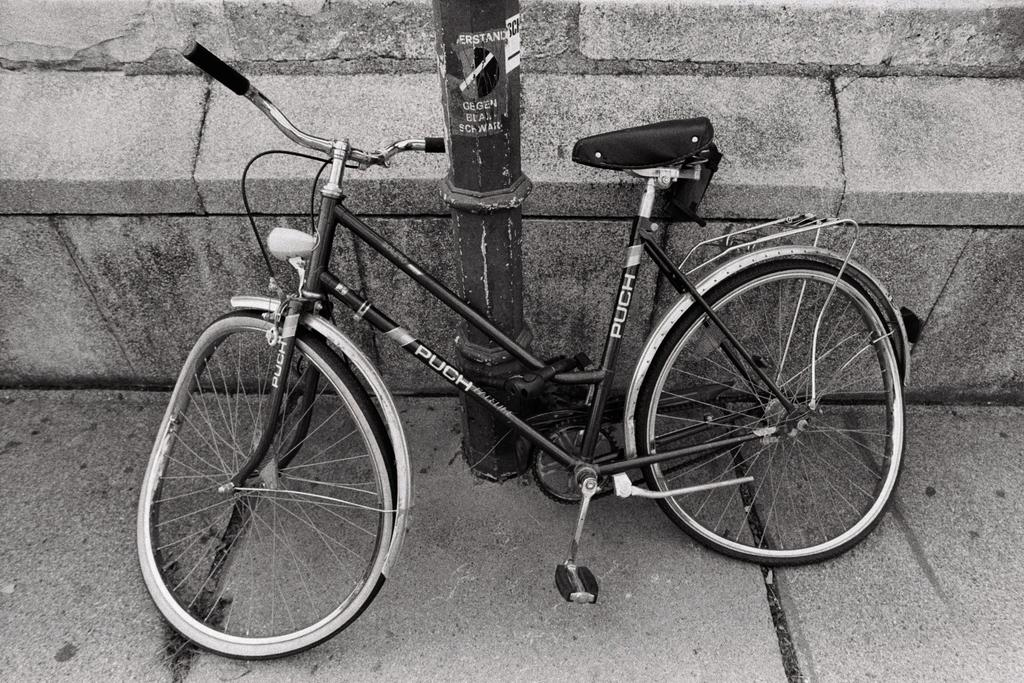What is the color scheme of the image? The image is black and white. What can be seen on the path in the image? There is a bicycle on a path in the image. What is visible in the background of the image? There is a pole and a wall in the background of the image. What type of cream is being used to paint the wall in the image? There is no cream or painting activity present in the image; it is a black and white photograph. 